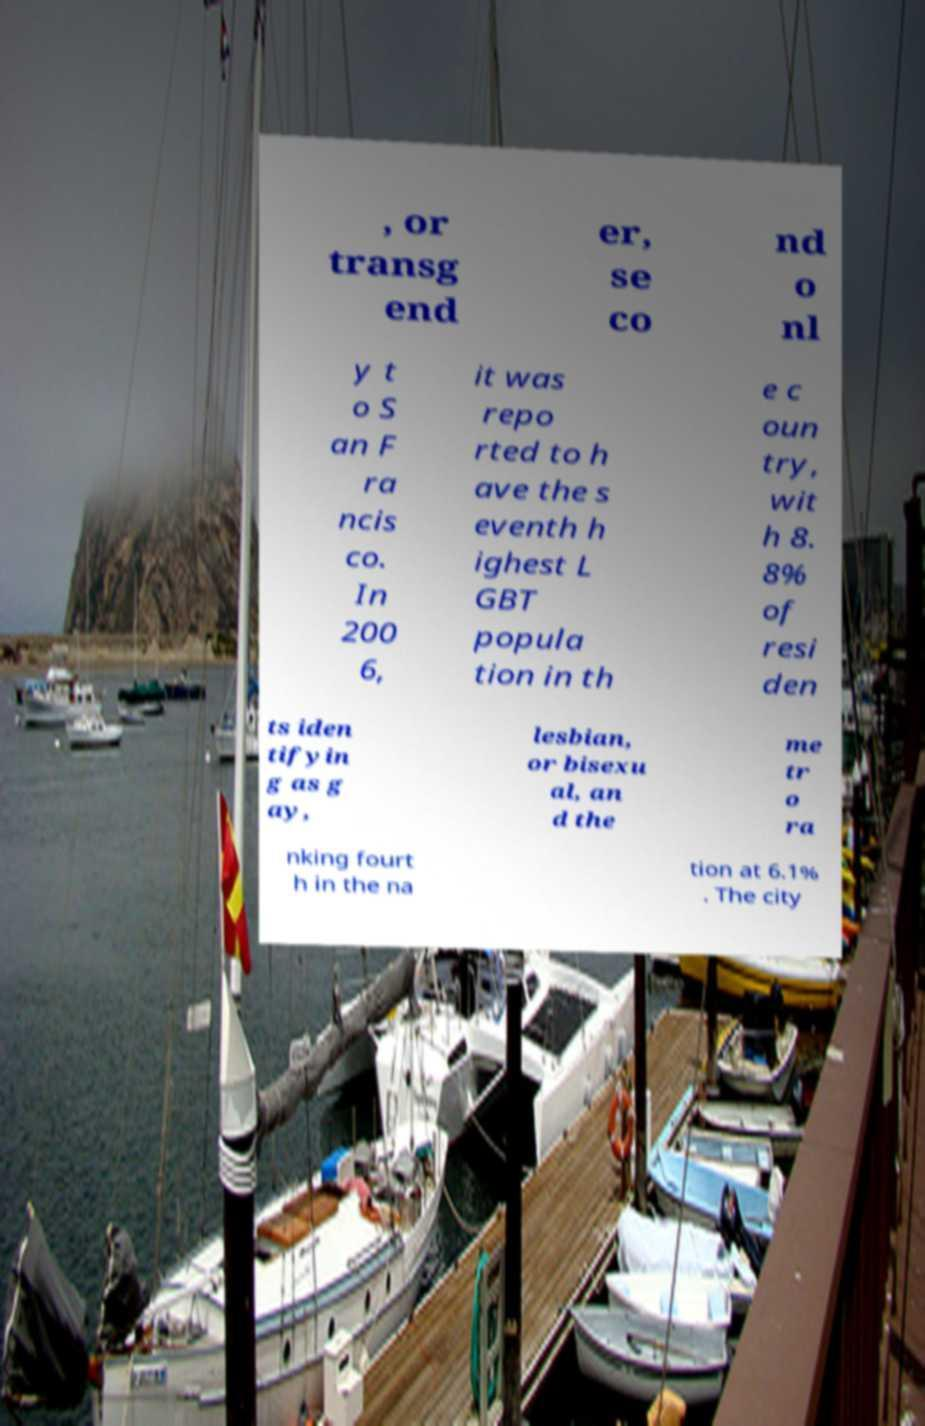Can you accurately transcribe the text from the provided image for me? , or transg end er, se co nd o nl y t o S an F ra ncis co. In 200 6, it was repo rted to h ave the s eventh h ighest L GBT popula tion in th e c oun try, wit h 8. 8% of resi den ts iden tifyin g as g ay, lesbian, or bisexu al, an d the me tr o ra nking fourt h in the na tion at 6.1% . The city 